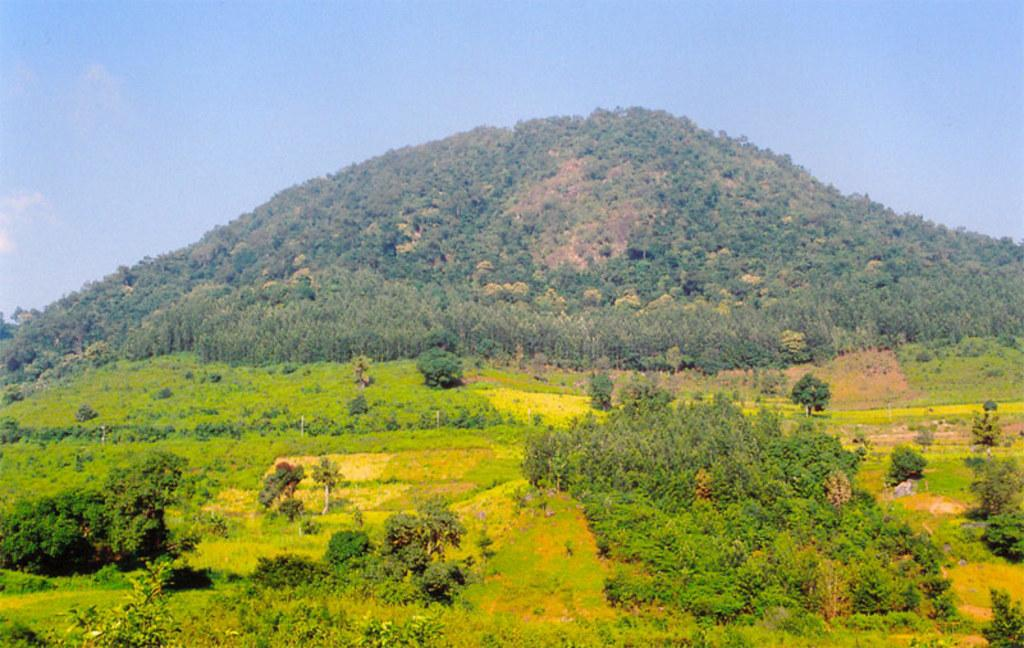What type of terrain is visible in the image? The image contains a grass-covered area. Are there any other natural elements in the image? Yes, there are trees in the image. What kind of geographical feature can be seen in the image? There are grass mountains in the image. What is the color of the sky in the image? The sky is blue in the image. Can you see any lizards resting on the grass mountains in the image? There are no lizards or any indication of resting animals in the image. Is there a band performing on the grass mountains in the image? There is no band or any musical performance depicted in the image. 